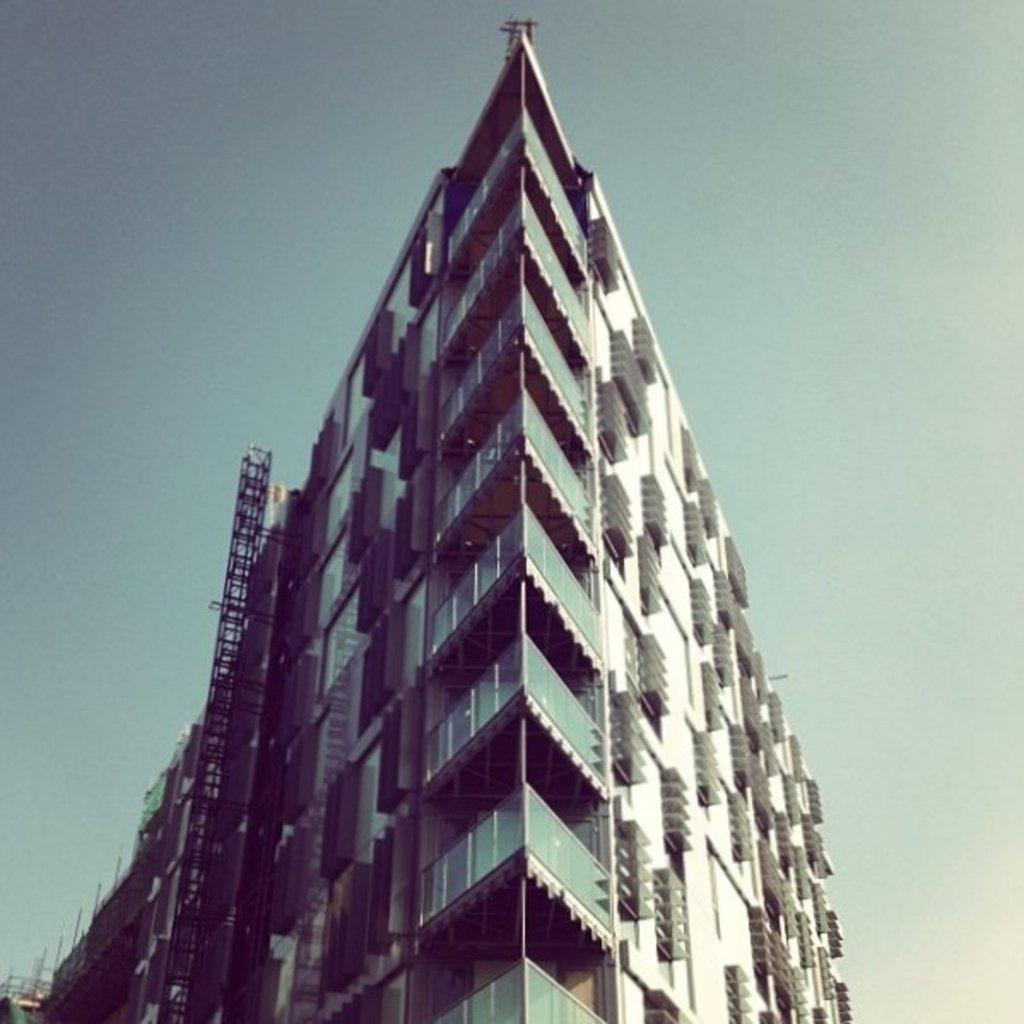What type of view is shown in the image? The image is an outside view. What structure can be seen in the image? There is a building in the image. What is visible at the top of the image? The sky is visible at the top of the image. Where is the pig standing in the image? There is no pig present in the image. 